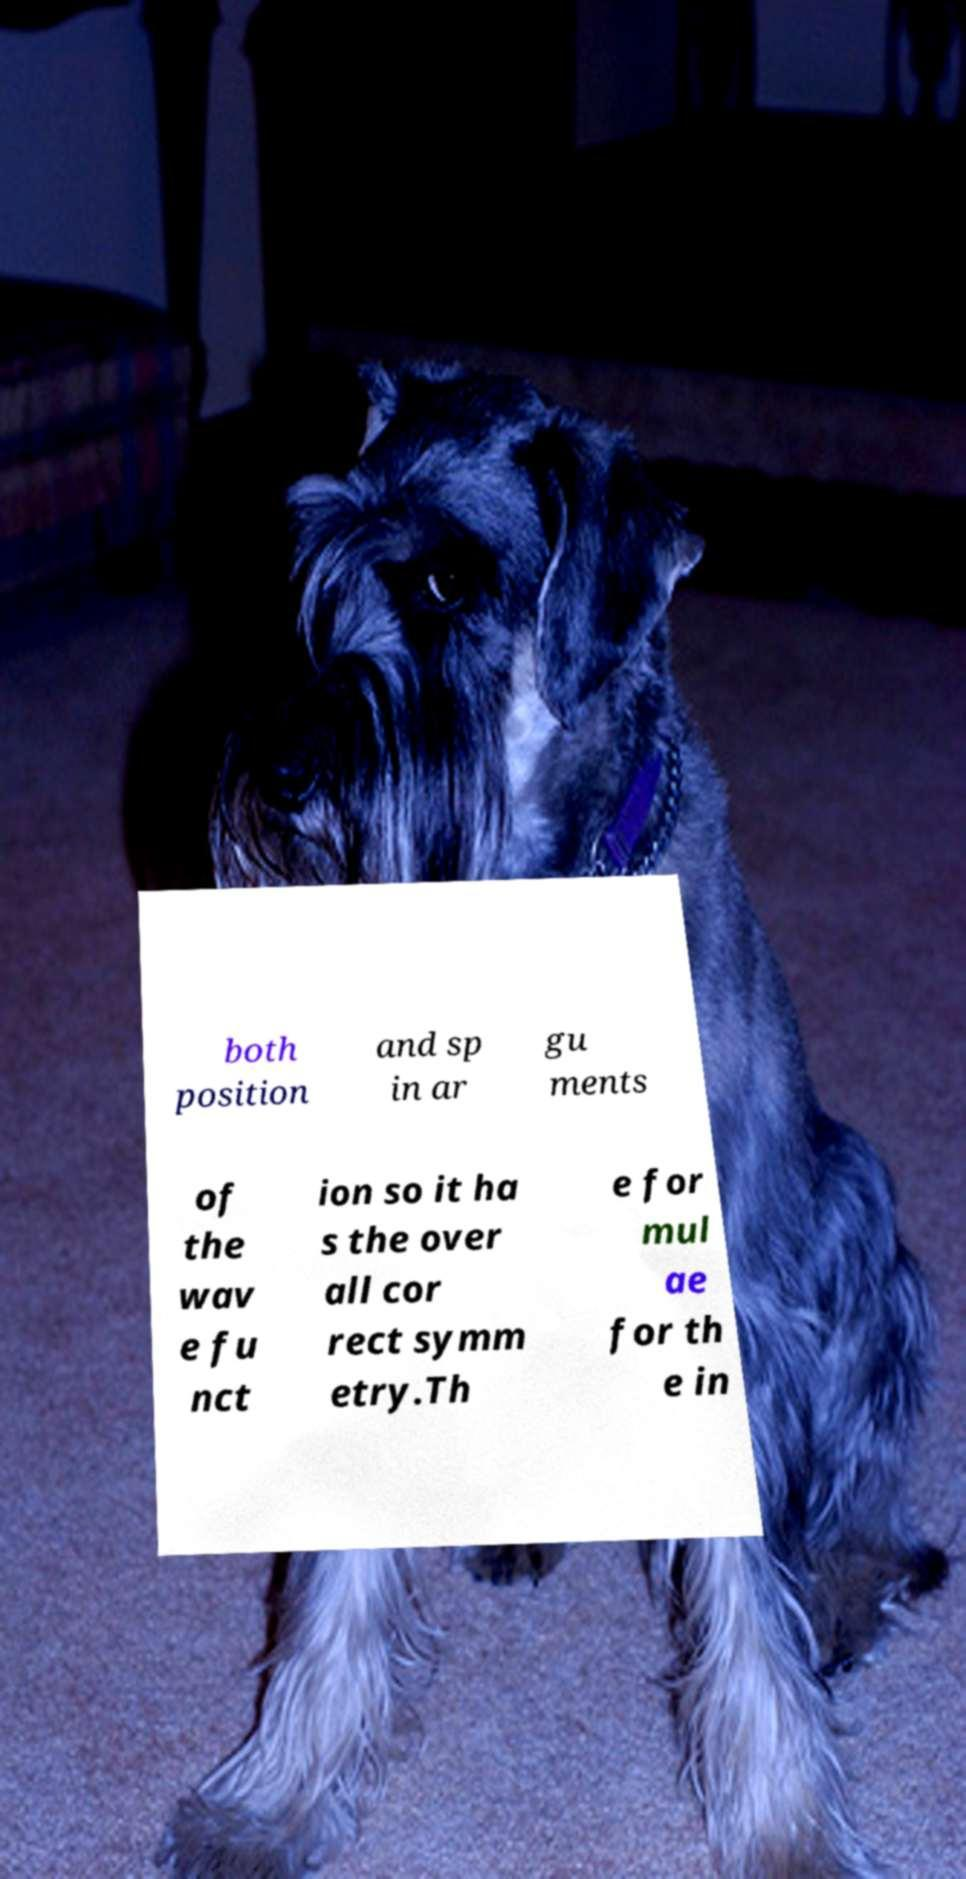Can you accurately transcribe the text from the provided image for me? both position and sp in ar gu ments of the wav e fu nct ion so it ha s the over all cor rect symm etry.Th e for mul ae for th e in 